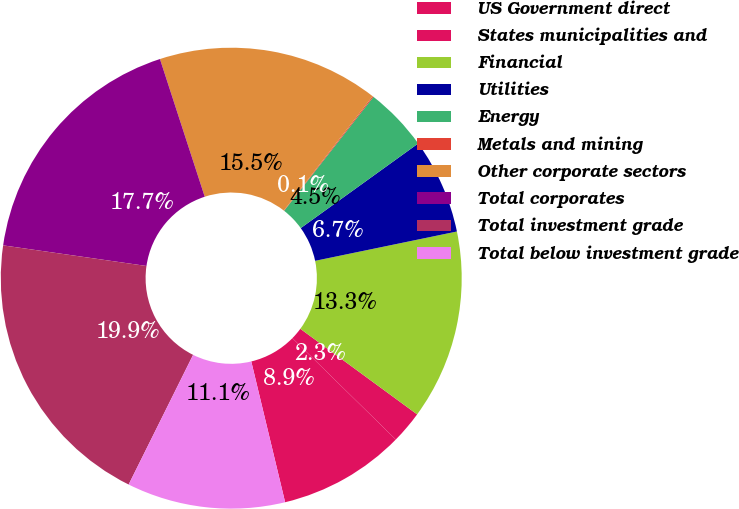Convert chart to OTSL. <chart><loc_0><loc_0><loc_500><loc_500><pie_chart><fcel>US Government direct<fcel>States municipalities and<fcel>Financial<fcel>Utilities<fcel>Energy<fcel>Metals and mining<fcel>Other corporate sectors<fcel>Total corporates<fcel>Total investment grade<fcel>Total below investment grade<nl><fcel>8.9%<fcel>2.28%<fcel>13.31%<fcel>6.69%<fcel>4.48%<fcel>0.07%<fcel>15.52%<fcel>17.72%<fcel>19.93%<fcel>11.1%<nl></chart> 